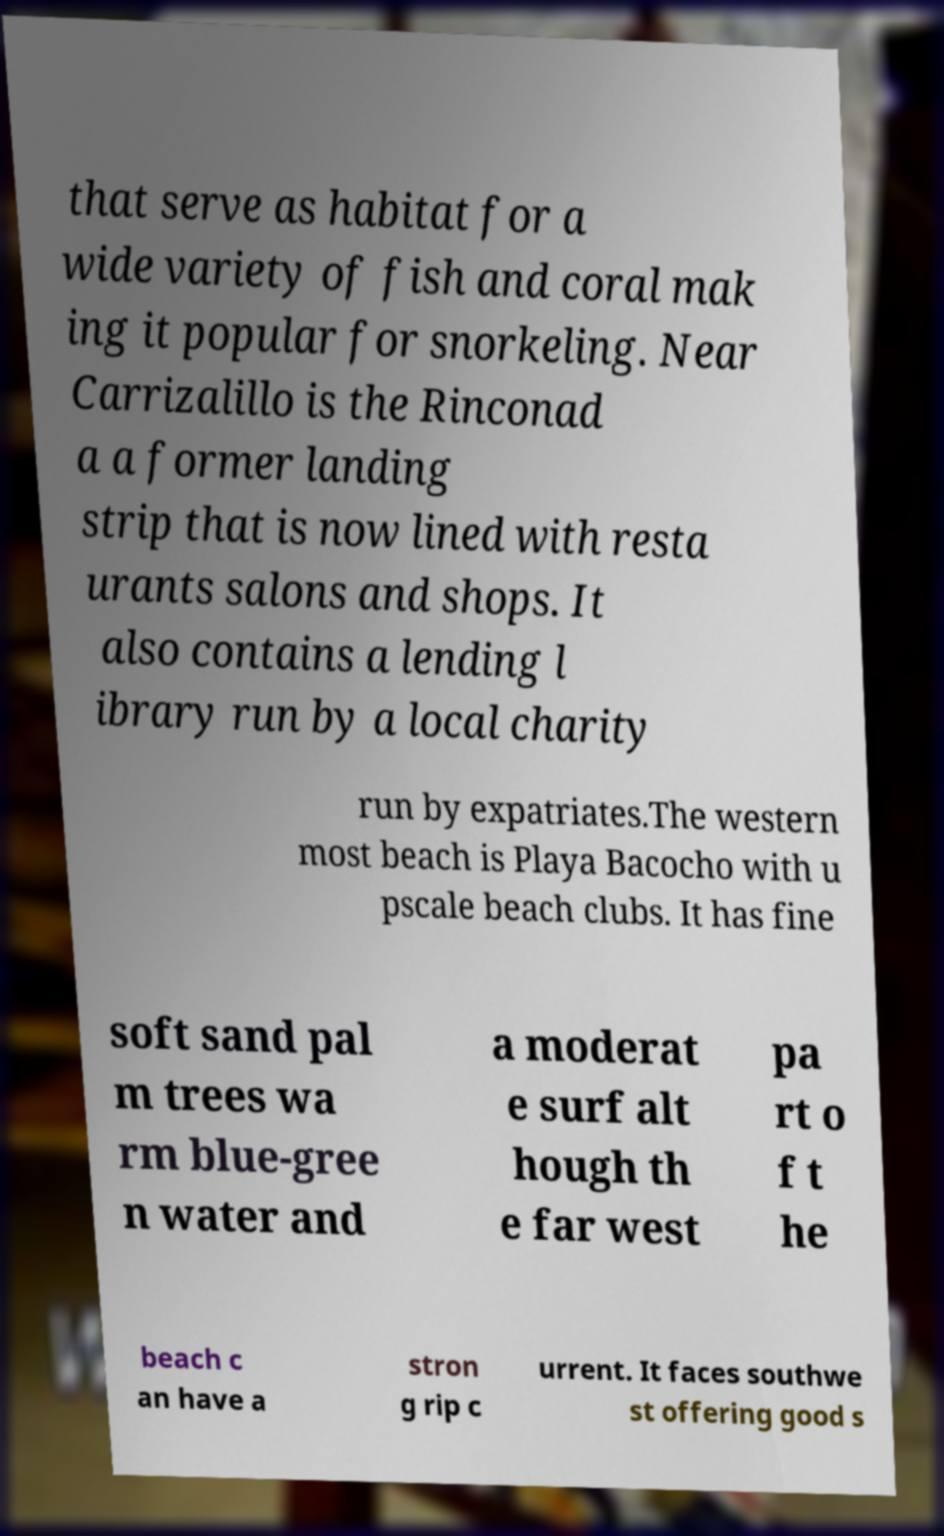Please read and relay the text visible in this image. What does it say? that serve as habitat for a wide variety of fish and coral mak ing it popular for snorkeling. Near Carrizalillo is the Rinconad a a former landing strip that is now lined with resta urants salons and shops. It also contains a lending l ibrary run by a local charity run by expatriates.The western most beach is Playa Bacocho with u pscale beach clubs. It has fine soft sand pal m trees wa rm blue-gree n water and a moderat e surf alt hough th e far west pa rt o f t he beach c an have a stron g rip c urrent. It faces southwe st offering good s 